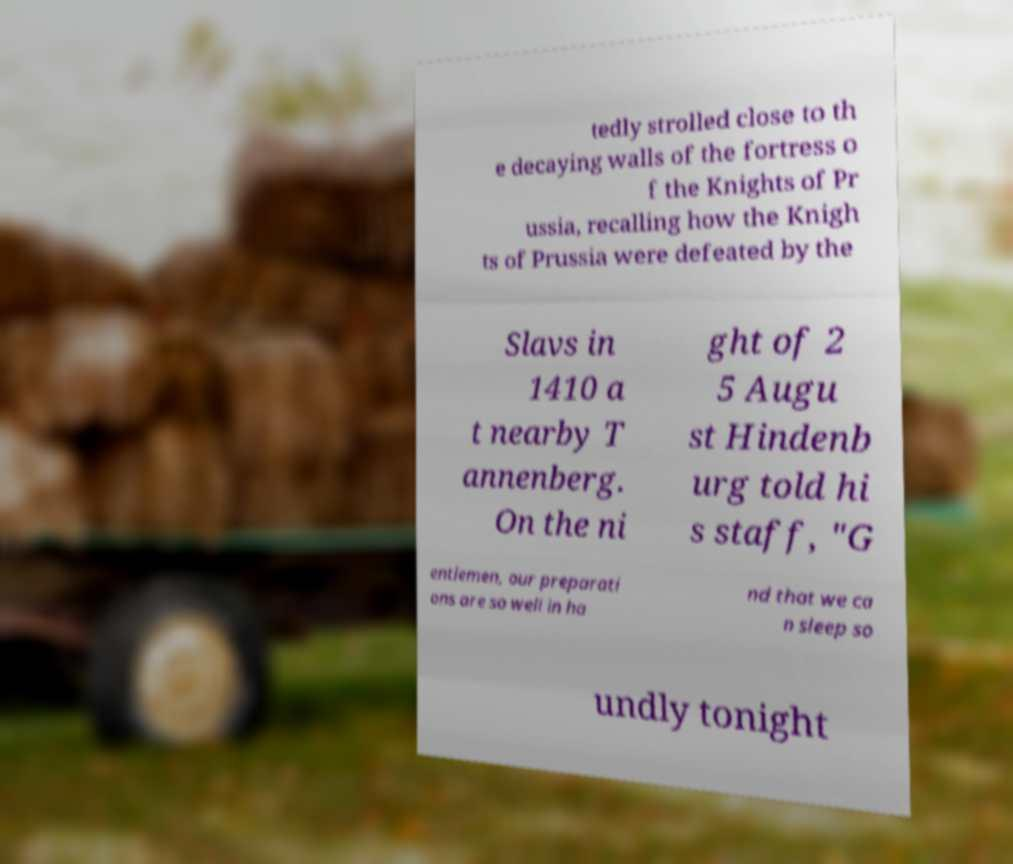Could you assist in decoding the text presented in this image and type it out clearly? tedly strolled close to th e decaying walls of the fortress o f the Knights of Pr ussia, recalling how the Knigh ts of Prussia were defeated by the Slavs in 1410 a t nearby T annenberg. On the ni ght of 2 5 Augu st Hindenb urg told hi s staff, "G entlemen, our preparati ons are so well in ha nd that we ca n sleep so undly tonight 